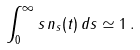Convert formula to latex. <formula><loc_0><loc_0><loc_500><loc_500>\int _ { 0 } ^ { \infty } s \, n _ { s } ( t ) \, d s \simeq 1 \, .</formula> 